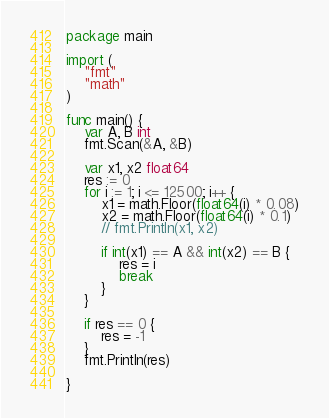Convert code to text. <code><loc_0><loc_0><loc_500><loc_500><_Go_>package main

import (
	"fmt"
	"math"
)

func main() {
	var A, B int
	fmt.Scan(&A, &B)

	var x1, x2 float64
	res := 0
	for i := 1; i <= 12500; i++ {
		x1 = math.Floor(float64(i) * 0.08)
		x2 = math.Floor(float64(i) * 0.1)
		// fmt.Println(x1, x2)

		if int(x1) == A && int(x2) == B {
			res = i
			break
		}
	}

	if res == 0 {
		res = -1
	}
	fmt.Println(res)

}
</code> 